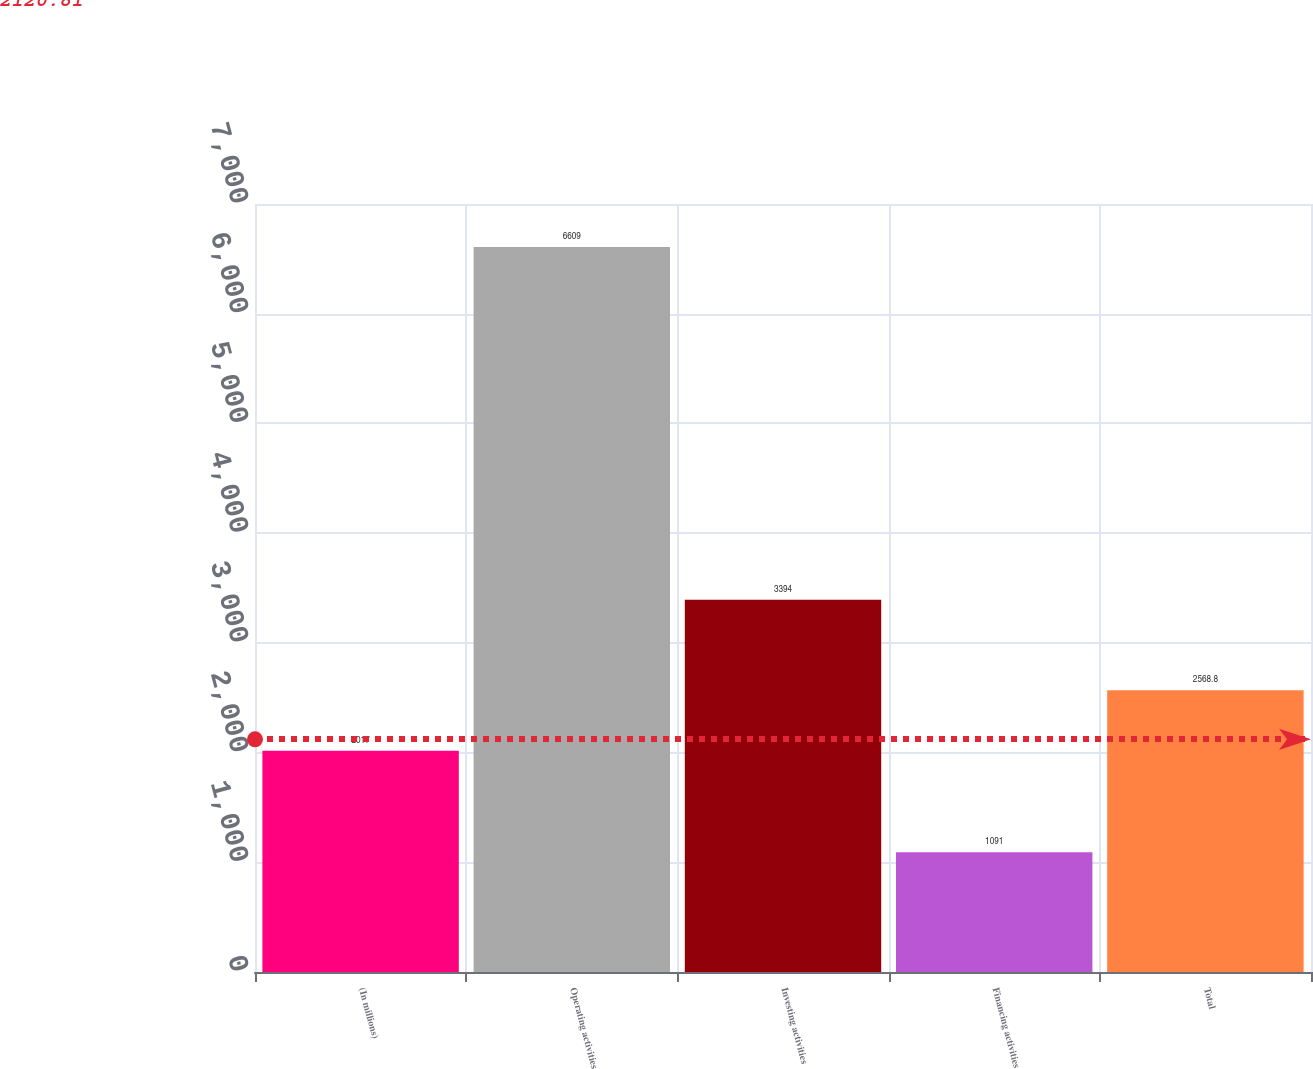Convert chart. <chart><loc_0><loc_0><loc_500><loc_500><bar_chart><fcel>(In millions)<fcel>Operating activities<fcel>Investing activities<fcel>Financing activities<fcel>Total<nl><fcel>2017<fcel>6609<fcel>3394<fcel>1091<fcel>2568.8<nl></chart> 